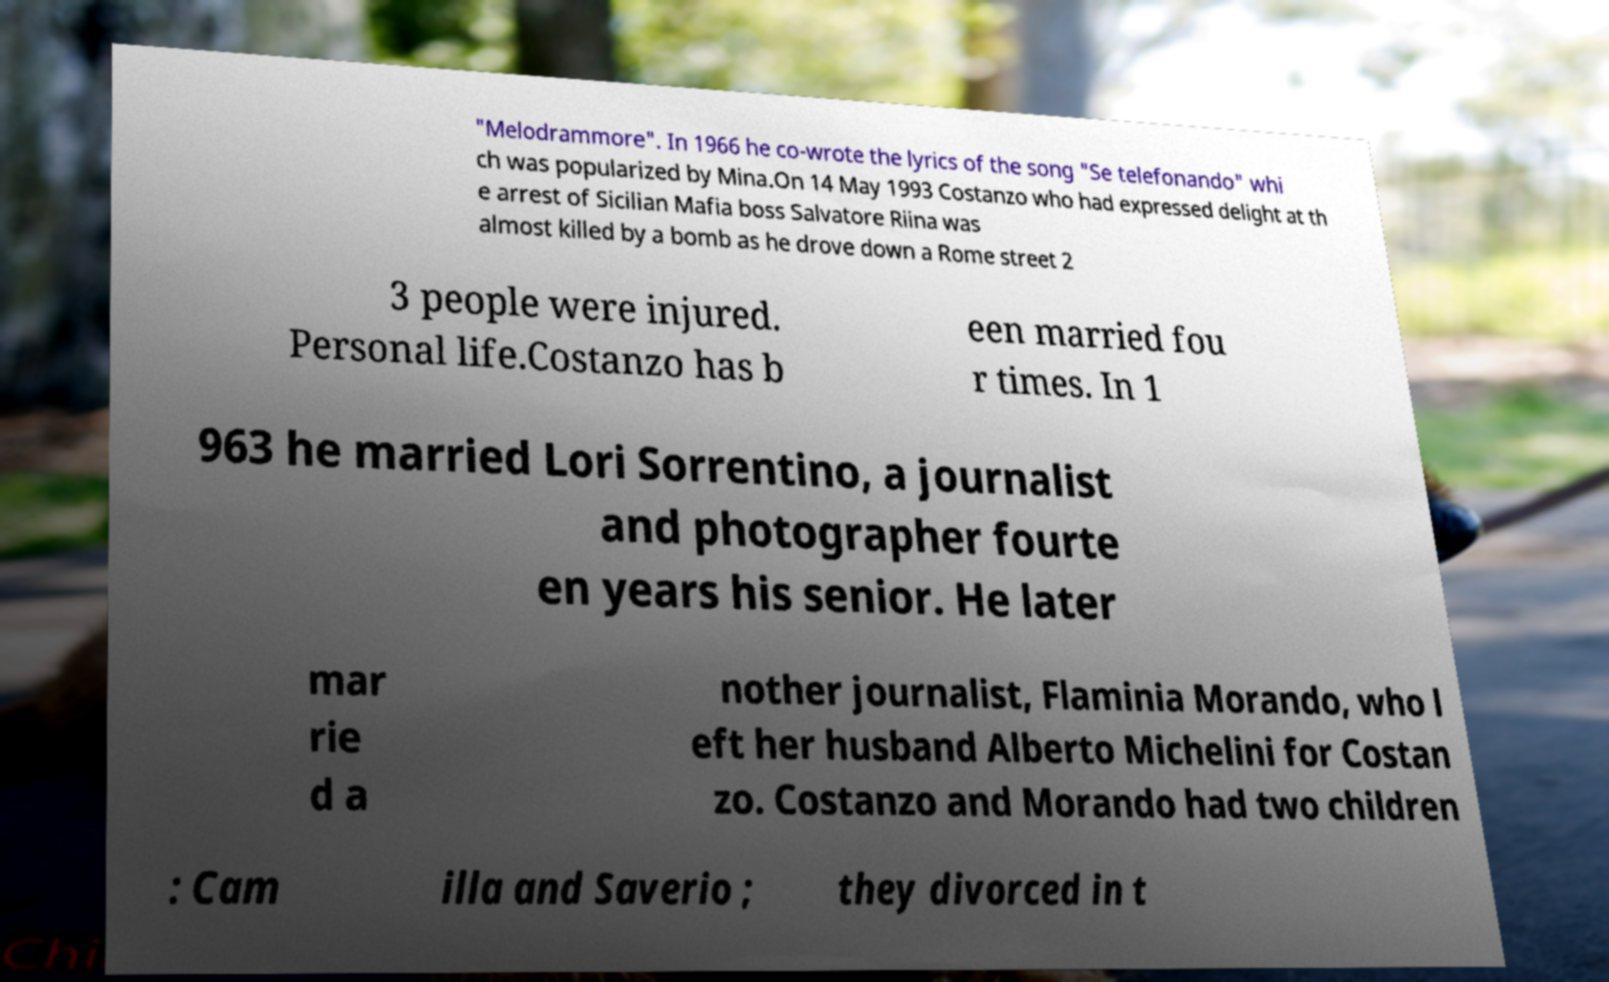Could you extract and type out the text from this image? "Melodrammore". In 1966 he co-wrote the lyrics of the song "Se telefonando" whi ch was popularized by Mina.On 14 May 1993 Costanzo who had expressed delight at th e arrest of Sicilian Mafia boss Salvatore Riina was almost killed by a bomb as he drove down a Rome street 2 3 people were injured. Personal life.Costanzo has b een married fou r times. In 1 963 he married Lori Sorrentino, a journalist and photographer fourte en years his senior. He later mar rie d a nother journalist, Flaminia Morando, who l eft her husband Alberto Michelini for Costan zo. Costanzo and Morando had two children : Cam illa and Saverio ; they divorced in t 